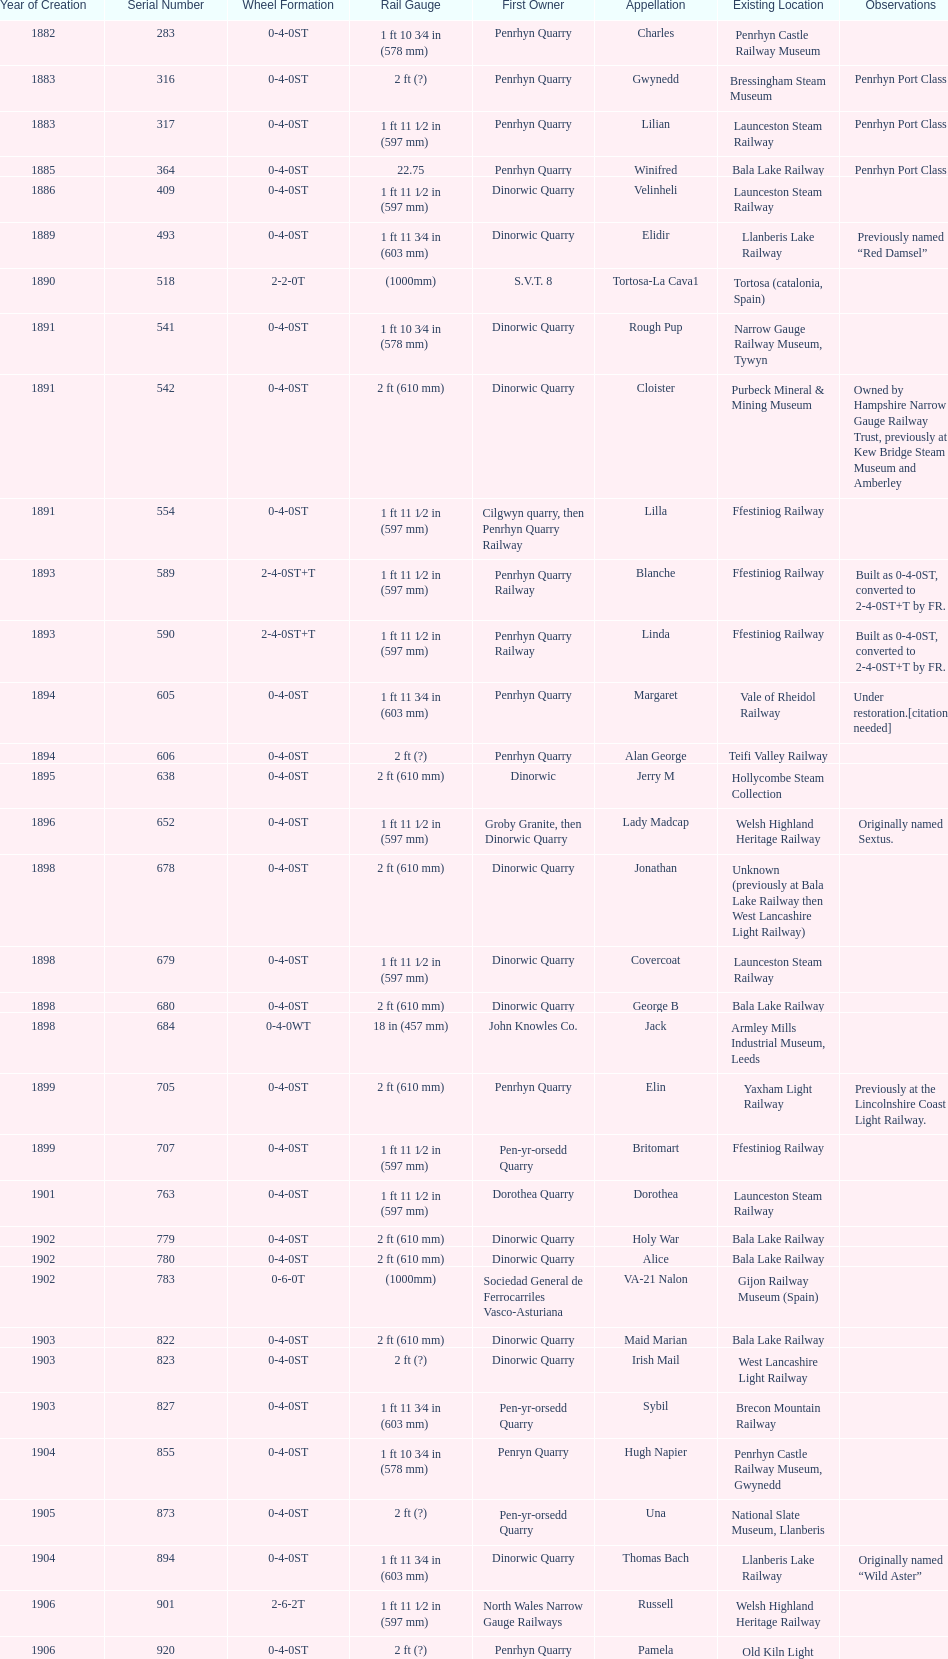Can you parse all the data within this table? {'header': ['Year of Creation', 'Serial Number', 'Wheel Formation', 'Rail Gauge', 'First Owner', 'Appellation', 'Existing Location', 'Observations'], 'rows': [['1882', '283', '0-4-0ST', '1\xa0ft 10\xa03⁄4\xa0in (578\xa0mm)', 'Penrhyn Quarry', 'Charles', 'Penrhyn Castle Railway Museum', ''], ['1883', '316', '0-4-0ST', '2\xa0ft (?)', 'Penrhyn Quarry', 'Gwynedd', 'Bressingham Steam Museum', 'Penrhyn Port Class'], ['1883', '317', '0-4-0ST', '1\xa0ft 11\xa01⁄2\xa0in (597\xa0mm)', 'Penrhyn Quarry', 'Lilian', 'Launceston Steam Railway', 'Penrhyn Port Class'], ['1885', '364', '0-4-0ST', '22.75', 'Penrhyn Quarry', 'Winifred', 'Bala Lake Railway', 'Penrhyn Port Class'], ['1886', '409', '0-4-0ST', '1\xa0ft 11\xa01⁄2\xa0in (597\xa0mm)', 'Dinorwic Quarry', 'Velinheli', 'Launceston Steam Railway', ''], ['1889', '493', '0-4-0ST', '1\xa0ft 11\xa03⁄4\xa0in (603\xa0mm)', 'Dinorwic Quarry', 'Elidir', 'Llanberis Lake Railway', 'Previously named “Red Damsel”'], ['1890', '518', '2-2-0T', '(1000mm)', 'S.V.T. 8', 'Tortosa-La Cava1', 'Tortosa (catalonia, Spain)', ''], ['1891', '541', '0-4-0ST', '1\xa0ft 10\xa03⁄4\xa0in (578\xa0mm)', 'Dinorwic Quarry', 'Rough Pup', 'Narrow Gauge Railway Museum, Tywyn', ''], ['1891', '542', '0-4-0ST', '2\xa0ft (610\xa0mm)', 'Dinorwic Quarry', 'Cloister', 'Purbeck Mineral & Mining Museum', 'Owned by Hampshire Narrow Gauge Railway Trust, previously at Kew Bridge Steam Museum and Amberley'], ['1891', '554', '0-4-0ST', '1\xa0ft 11\xa01⁄2\xa0in (597\xa0mm)', 'Cilgwyn quarry, then Penrhyn Quarry Railway', 'Lilla', 'Ffestiniog Railway', ''], ['1893', '589', '2-4-0ST+T', '1\xa0ft 11\xa01⁄2\xa0in (597\xa0mm)', 'Penrhyn Quarry Railway', 'Blanche', 'Ffestiniog Railway', 'Built as 0-4-0ST, converted to 2-4-0ST+T by FR.'], ['1893', '590', '2-4-0ST+T', '1\xa0ft 11\xa01⁄2\xa0in (597\xa0mm)', 'Penrhyn Quarry Railway', 'Linda', 'Ffestiniog Railway', 'Built as 0-4-0ST, converted to 2-4-0ST+T by FR.'], ['1894', '605', '0-4-0ST', '1\xa0ft 11\xa03⁄4\xa0in (603\xa0mm)', 'Penrhyn Quarry', 'Margaret', 'Vale of Rheidol Railway', 'Under restoration.[citation needed]'], ['1894', '606', '0-4-0ST', '2\xa0ft (?)', 'Penrhyn Quarry', 'Alan George', 'Teifi Valley Railway', ''], ['1895', '638', '0-4-0ST', '2\xa0ft (610\xa0mm)', 'Dinorwic', 'Jerry M', 'Hollycombe Steam Collection', ''], ['1896', '652', '0-4-0ST', '1\xa0ft 11\xa01⁄2\xa0in (597\xa0mm)', 'Groby Granite, then Dinorwic Quarry', 'Lady Madcap', 'Welsh Highland Heritage Railway', 'Originally named Sextus.'], ['1898', '678', '0-4-0ST', '2\xa0ft (610\xa0mm)', 'Dinorwic Quarry', 'Jonathan', 'Unknown (previously at Bala Lake Railway then West Lancashire Light Railway)', ''], ['1898', '679', '0-4-0ST', '1\xa0ft 11\xa01⁄2\xa0in (597\xa0mm)', 'Dinorwic Quarry', 'Covercoat', 'Launceston Steam Railway', ''], ['1898', '680', '0-4-0ST', '2\xa0ft (610\xa0mm)', 'Dinorwic Quarry', 'George B', 'Bala Lake Railway', ''], ['1898', '684', '0-4-0WT', '18\xa0in (457\xa0mm)', 'John Knowles Co.', 'Jack', 'Armley Mills Industrial Museum, Leeds', ''], ['1899', '705', '0-4-0ST', '2\xa0ft (610\xa0mm)', 'Penrhyn Quarry', 'Elin', 'Yaxham Light Railway', 'Previously at the Lincolnshire Coast Light Railway.'], ['1899', '707', '0-4-0ST', '1\xa0ft 11\xa01⁄2\xa0in (597\xa0mm)', 'Pen-yr-orsedd Quarry', 'Britomart', 'Ffestiniog Railway', ''], ['1901', '763', '0-4-0ST', '1\xa0ft 11\xa01⁄2\xa0in (597\xa0mm)', 'Dorothea Quarry', 'Dorothea', 'Launceston Steam Railway', ''], ['1902', '779', '0-4-0ST', '2\xa0ft (610\xa0mm)', 'Dinorwic Quarry', 'Holy War', 'Bala Lake Railway', ''], ['1902', '780', '0-4-0ST', '2\xa0ft (610\xa0mm)', 'Dinorwic Quarry', 'Alice', 'Bala Lake Railway', ''], ['1902', '783', '0-6-0T', '(1000mm)', 'Sociedad General de Ferrocarriles Vasco-Asturiana', 'VA-21 Nalon', 'Gijon Railway Museum (Spain)', ''], ['1903', '822', '0-4-0ST', '2\xa0ft (610\xa0mm)', 'Dinorwic Quarry', 'Maid Marian', 'Bala Lake Railway', ''], ['1903', '823', '0-4-0ST', '2\xa0ft (?)', 'Dinorwic Quarry', 'Irish Mail', 'West Lancashire Light Railway', ''], ['1903', '827', '0-4-0ST', '1\xa0ft 11\xa03⁄4\xa0in (603\xa0mm)', 'Pen-yr-orsedd Quarry', 'Sybil', 'Brecon Mountain Railway', ''], ['1904', '855', '0-4-0ST', '1\xa0ft 10\xa03⁄4\xa0in (578\xa0mm)', 'Penryn Quarry', 'Hugh Napier', 'Penrhyn Castle Railway Museum, Gwynedd', ''], ['1905', '873', '0-4-0ST', '2\xa0ft (?)', 'Pen-yr-orsedd Quarry', 'Una', 'National Slate Museum, Llanberis', ''], ['1904', '894', '0-4-0ST', '1\xa0ft 11\xa03⁄4\xa0in (603\xa0mm)', 'Dinorwic Quarry', 'Thomas Bach', 'Llanberis Lake Railway', 'Originally named “Wild Aster”'], ['1906', '901', '2-6-2T', '1\xa0ft 11\xa01⁄2\xa0in (597\xa0mm)', 'North Wales Narrow Gauge Railways', 'Russell', 'Welsh Highland Heritage Railway', ''], ['1906', '920', '0-4-0ST', '2\xa0ft (?)', 'Penrhyn Quarry', 'Pamela', 'Old Kiln Light Railway', ''], ['1909', '994', '0-4-0ST', '2\xa0ft (?)', 'Penrhyn Quarry', 'Bill Harvey', 'Bressingham Steam Museum', 'previously George Sholto'], ['1918', '1312', '4-6-0T', '1\xa0ft\xa011\xa01⁄2\xa0in (597\xa0mm)', 'British War Department\\nEFOP #203', '---', 'Pampas Safari, Gravataí, RS, Brazil', '[citation needed]'], ['1918\\nor\\n1921?', '1313', '0-6-2T', '3\xa0ft\xa03\xa03⁄8\xa0in (1,000\xa0mm)', 'British War Department\\nUsina Leão Utinga #1\\nUsina Laginha #1', '---', 'Usina Laginha, União dos Palmares, AL, Brazil', '[citation needed]'], ['1920', '1404', '0-4-0WT', '18\xa0in (457\xa0mm)', 'John Knowles Co.', 'Gwen', 'Richard Farmer current owner, Northridge, California, USA', ''], ['1922', '1429', '0-4-0ST', '2\xa0ft (610\xa0mm)', 'Dinorwic', 'Lady Joan', 'Bredgar and Wormshill Light Railway', ''], ['1922', '1430', '0-4-0ST', '1\xa0ft 11\xa03⁄4\xa0in (603\xa0mm)', 'Dinorwic Quarry', 'Dolbadarn', 'Llanberis Lake Railway', ''], ['1937', '1859', '0-4-2T', '2\xa0ft (?)', 'Umtwalumi Valley Estate, Natal', '16 Carlisle', 'South Tynedale Railway', ''], ['1940', '2075', '0-4-2T', '2\xa0ft (?)', 'Chaka’s Kraal Sugar Estates, Natal', 'Chaka’s Kraal No. 6', 'North Gloucestershire Railway', ''], ['1954', '3815', '2-6-2T', '2\xa0ft 6\xa0in (762\xa0mm)', 'Sierra Leone Government Railway', '14', 'Welshpool and Llanfair Light Railway', ''], ['1971', '3902', '0-4-2ST', '2\xa0ft (610\xa0mm)', 'Trangkil Sugar Mill, Indonesia', 'Trangkil No.4', 'Statfold Barn Railway', 'Converted from 750\xa0mm (2\xa0ft\xa05\xa01⁄2\xa0in) gauge. Last steam locomotive to be built by Hunslet, and the last industrial steam locomotive built in Britain.']]} In which year were the most steam locomotives built? 1898. 